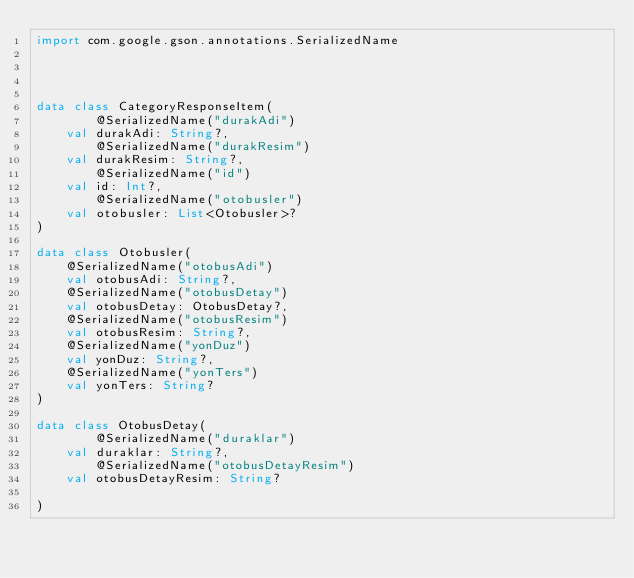<code> <loc_0><loc_0><loc_500><loc_500><_Kotlin_>import com.google.gson.annotations.SerializedName




data class CategoryResponseItem(
        @SerializedName("durakAdi")
    val durakAdi: String?,
        @SerializedName("durakResim")
    val durakResim: String?,
        @SerializedName("id")
    val id: Int?,
        @SerializedName("otobusler")
    val otobusler: List<Otobusler>?
)

data class Otobusler(
    @SerializedName("otobusAdi")
    val otobusAdi: String?,
    @SerializedName("otobusDetay")
    val otobusDetay: OtobusDetay?,
    @SerializedName("otobusResim")
    val otobusResim: String?,
    @SerializedName("yonDuz")
    val yonDuz: String?,
    @SerializedName("yonTers")
    val yonTers: String?
)

data class OtobusDetay(
        @SerializedName("duraklar")
    val duraklar: String?,
        @SerializedName("otobusDetayResim")
    val otobusDetayResim: String?

)
</code> 